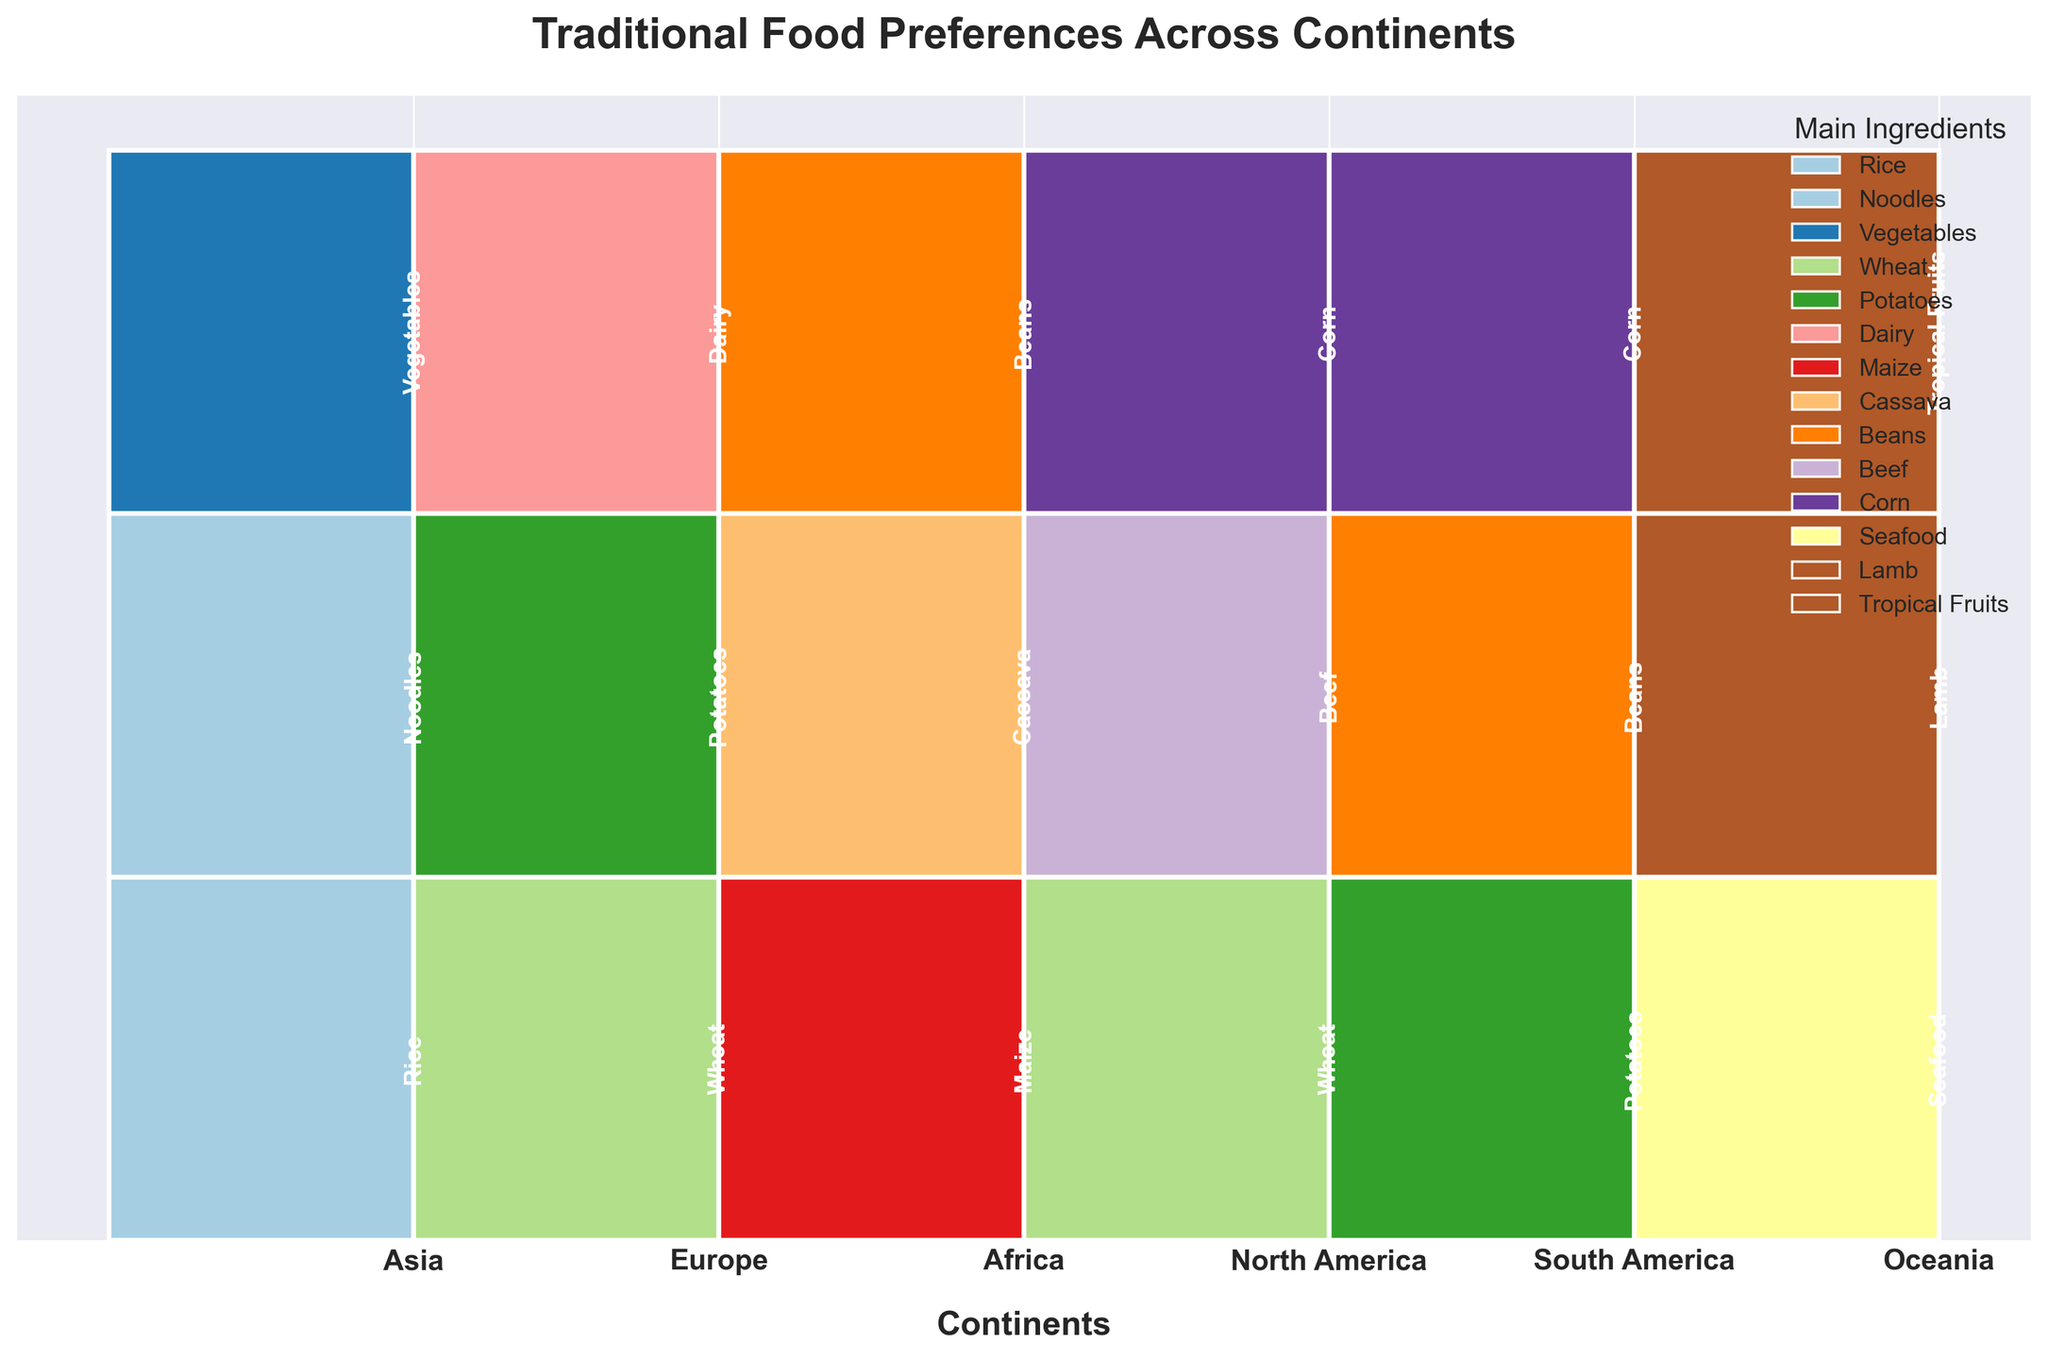How many continents are shown in the figure? The figure lists the continents on the x-axis, which can be counted.
Answer: 6 Which ingredient has the highest popularity in Oceania? For Oceania, look at the largest section which is on the far right. The section with the highest bar is colored differently and labeled.
Answer: Seafood What is the main ingredient with medium popularity common to both Asia and Europe? Check both Asia and Europe sections for the ingredient with medium-sized bars and labels. The shared ingredient in both regions needs to be identified.
Answer: Vegetables Which continent has Beans as a high popularity ingredient? Look for the continent bar with a large segment, filled with the color representing Beans and labeled accordingly.
Answer: South America If we sum the popularity sizes of Maize, Cassava, and Beans in Africa, does it equal the sum of Noodles and Vegetables in Asia? Calculate the total popularity for the three ingredients in Africa and compare it to the sum of the two in Asia. Each ingredient's size is visually represented.
Answer: Yes Do all continents have exactly three main ingredients represented? Each continent's section should be checked to count the number of distinct ingredients present.
Answer: Yes Which continent represents Wheat as a medium popularity ingredient apart from Europe? Observe continents, excluding Europe, and find if Wheat is shown in a size smaller than the top but larger than the smallest.
Answer: North America Is the popularity of Potatoes higher in Europe or South America? Compare the segments labeled “Potatoes” in the Europe and South America columns by examining their sizes visually.
Answer: Europe Explain why Oceania might have a smaller section in the Mosaic Plot. Analyze which factor causes the reduced width in the plot for Oceania; likely fewer unique ingredients or smaller population sample.
Answer: Fewer unique ingredients 